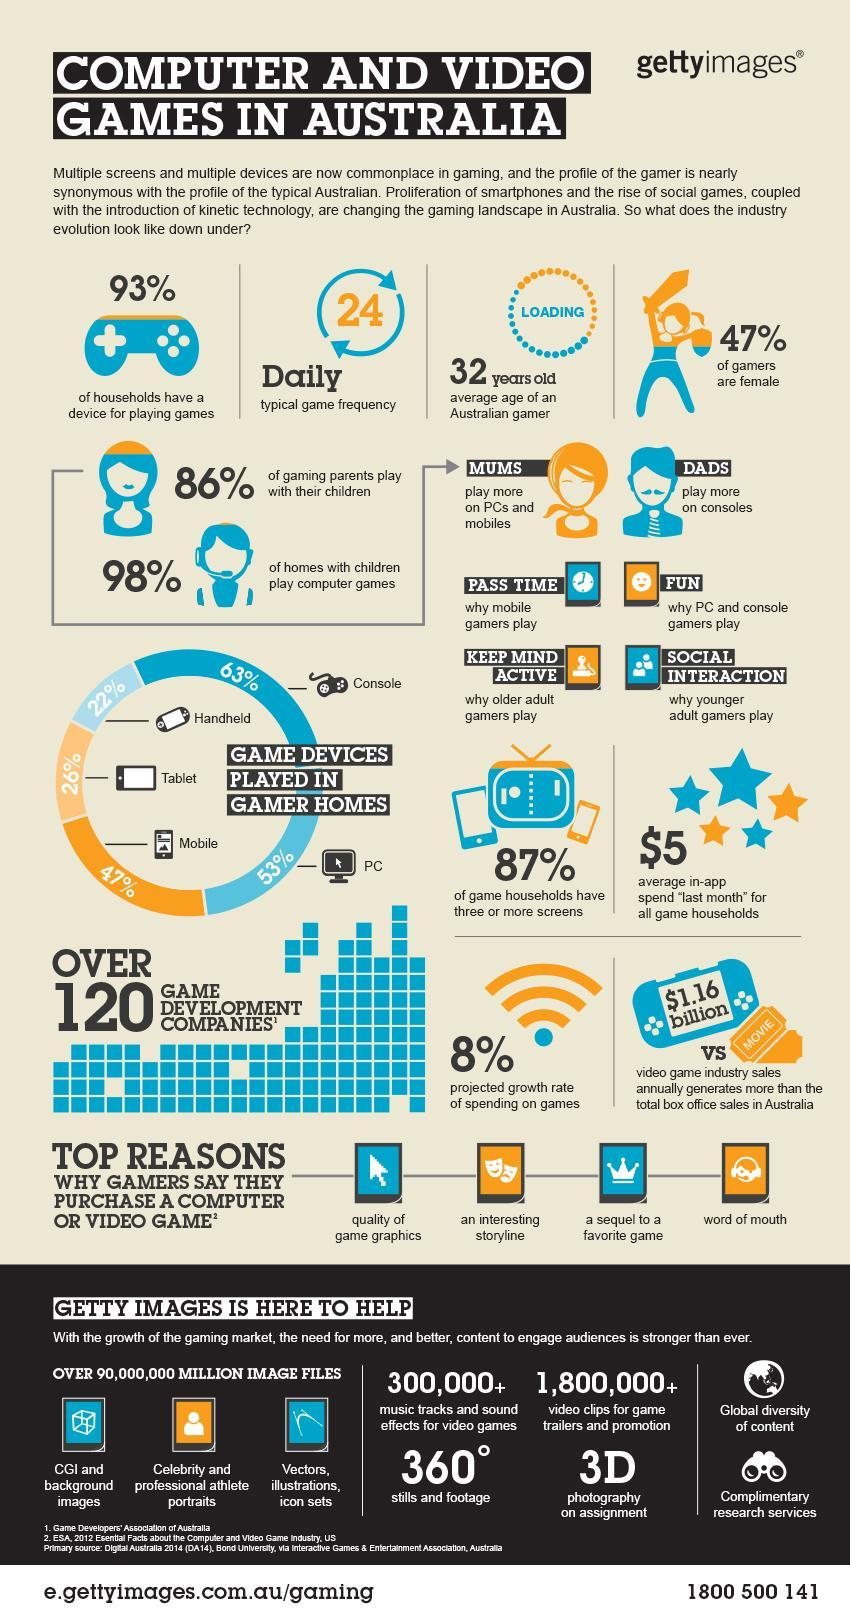What is the average age of an Australian gamer?
Answer the question with a short phrase. 32 years old What percentage of homes with children do not play computer games in Australia? 2% What is the daily typical game frequency of an Australian gamer? 24 What is the projected growth rate of spending on games in Australia? 8% What is the sales revenue generated by video game industry annually in Australia? $1.16 billion What percentage of gamers use tablet as the gaming device in Australia? 26% What percentage of gamers use PC as the gaming device in Australia? 53% What percentage of gamers use console as the gaming device in Australia? 63% What percentage of gamers are females in Australia? 47% What percentage of gaming parents do not play with their children in Australia? 14% 